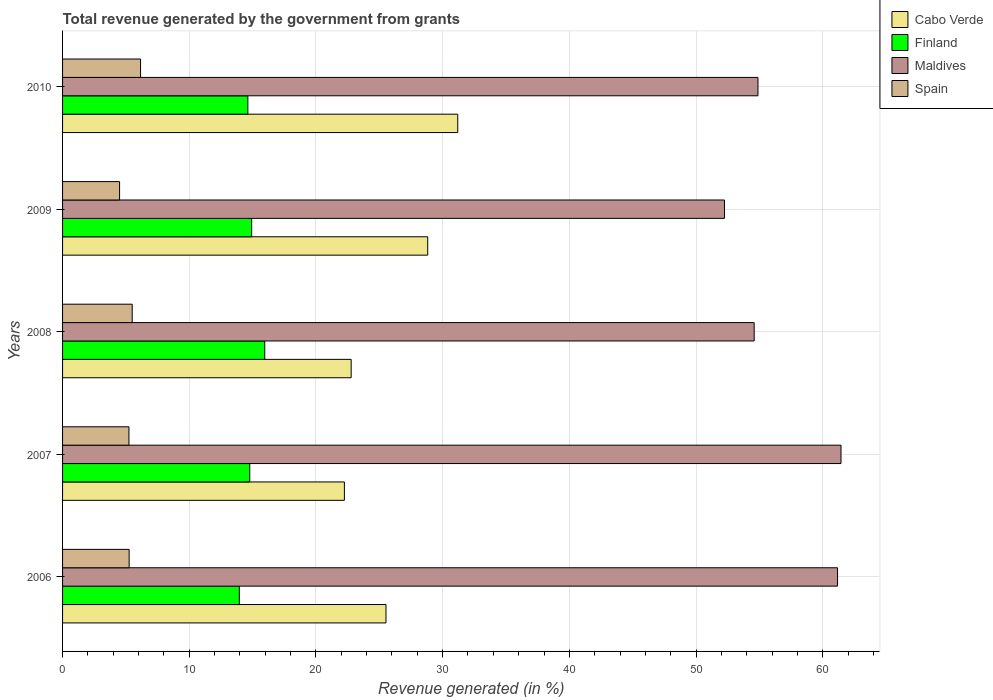How many different coloured bars are there?
Provide a succinct answer. 4. Are the number of bars on each tick of the Y-axis equal?
Make the answer very short. Yes. What is the total revenue generated in Spain in 2009?
Ensure brevity in your answer.  4.5. Across all years, what is the maximum total revenue generated in Spain?
Make the answer very short. 6.16. Across all years, what is the minimum total revenue generated in Maldives?
Ensure brevity in your answer.  52.25. In which year was the total revenue generated in Spain minimum?
Give a very brief answer. 2009. What is the total total revenue generated in Finland in the graph?
Offer a very short reply. 74.24. What is the difference between the total revenue generated in Cabo Verde in 2006 and that in 2010?
Give a very brief answer. -5.66. What is the difference between the total revenue generated in Maldives in 2010 and the total revenue generated in Cabo Verde in 2009?
Provide a succinct answer. 26.07. What is the average total revenue generated in Maldives per year?
Keep it short and to the point. 56.87. In the year 2009, what is the difference between the total revenue generated in Finland and total revenue generated in Maldives?
Provide a short and direct response. -37.32. What is the ratio of the total revenue generated in Maldives in 2006 to that in 2010?
Your answer should be very brief. 1.11. Is the difference between the total revenue generated in Finland in 2006 and 2008 greater than the difference between the total revenue generated in Maldives in 2006 and 2008?
Offer a terse response. No. What is the difference between the highest and the second highest total revenue generated in Finland?
Make the answer very short. 1.03. What is the difference between the highest and the lowest total revenue generated in Maldives?
Ensure brevity in your answer.  9.2. In how many years, is the total revenue generated in Finland greater than the average total revenue generated in Finland taken over all years?
Ensure brevity in your answer.  2. What does the 1st bar from the top in 2008 represents?
Offer a terse response. Spain. Is it the case that in every year, the sum of the total revenue generated in Cabo Verde and total revenue generated in Finland is greater than the total revenue generated in Maldives?
Offer a terse response. No. How many years are there in the graph?
Make the answer very short. 5. Are the values on the major ticks of X-axis written in scientific E-notation?
Provide a short and direct response. No. Does the graph contain any zero values?
Give a very brief answer. No. Where does the legend appear in the graph?
Offer a very short reply. Top right. How many legend labels are there?
Make the answer very short. 4. How are the legend labels stacked?
Provide a succinct answer. Vertical. What is the title of the graph?
Your response must be concise. Total revenue generated by the government from grants. Does "Azerbaijan" appear as one of the legend labels in the graph?
Your answer should be very brief. No. What is the label or title of the X-axis?
Ensure brevity in your answer.  Revenue generated (in %). What is the Revenue generated (in %) in Cabo Verde in 2006?
Your answer should be compact. 25.53. What is the Revenue generated (in %) of Finland in 2006?
Offer a very short reply. 13.95. What is the Revenue generated (in %) of Maldives in 2006?
Provide a short and direct response. 61.17. What is the Revenue generated (in %) of Spain in 2006?
Your answer should be very brief. 5.26. What is the Revenue generated (in %) in Cabo Verde in 2007?
Make the answer very short. 22.25. What is the Revenue generated (in %) in Finland in 2007?
Keep it short and to the point. 14.78. What is the Revenue generated (in %) in Maldives in 2007?
Your answer should be very brief. 61.44. What is the Revenue generated (in %) of Spain in 2007?
Your answer should be very brief. 5.24. What is the Revenue generated (in %) of Cabo Verde in 2008?
Provide a short and direct response. 22.78. What is the Revenue generated (in %) in Finland in 2008?
Your response must be concise. 15.96. What is the Revenue generated (in %) in Maldives in 2008?
Provide a succinct answer. 54.59. What is the Revenue generated (in %) in Spain in 2008?
Ensure brevity in your answer.  5.5. What is the Revenue generated (in %) in Cabo Verde in 2009?
Keep it short and to the point. 28.82. What is the Revenue generated (in %) of Finland in 2009?
Provide a short and direct response. 14.93. What is the Revenue generated (in %) in Maldives in 2009?
Offer a terse response. 52.25. What is the Revenue generated (in %) in Spain in 2009?
Provide a short and direct response. 4.5. What is the Revenue generated (in %) in Cabo Verde in 2010?
Provide a succinct answer. 31.19. What is the Revenue generated (in %) of Finland in 2010?
Offer a very short reply. 14.62. What is the Revenue generated (in %) of Maldives in 2010?
Ensure brevity in your answer.  54.89. What is the Revenue generated (in %) in Spain in 2010?
Offer a terse response. 6.16. Across all years, what is the maximum Revenue generated (in %) of Cabo Verde?
Provide a succinct answer. 31.19. Across all years, what is the maximum Revenue generated (in %) in Finland?
Your answer should be very brief. 15.96. Across all years, what is the maximum Revenue generated (in %) of Maldives?
Give a very brief answer. 61.44. Across all years, what is the maximum Revenue generated (in %) of Spain?
Offer a very short reply. 6.16. Across all years, what is the minimum Revenue generated (in %) of Cabo Verde?
Keep it short and to the point. 22.25. Across all years, what is the minimum Revenue generated (in %) in Finland?
Provide a short and direct response. 13.95. Across all years, what is the minimum Revenue generated (in %) in Maldives?
Offer a very short reply. 52.25. Across all years, what is the minimum Revenue generated (in %) in Spain?
Your answer should be very brief. 4.5. What is the total Revenue generated (in %) of Cabo Verde in the graph?
Keep it short and to the point. 130.57. What is the total Revenue generated (in %) of Finland in the graph?
Your response must be concise. 74.24. What is the total Revenue generated (in %) in Maldives in the graph?
Provide a short and direct response. 284.34. What is the total Revenue generated (in %) of Spain in the graph?
Keep it short and to the point. 26.65. What is the difference between the Revenue generated (in %) in Cabo Verde in 2006 and that in 2007?
Your response must be concise. 3.28. What is the difference between the Revenue generated (in %) of Finland in 2006 and that in 2007?
Provide a succinct answer. -0.82. What is the difference between the Revenue generated (in %) of Maldives in 2006 and that in 2007?
Your answer should be very brief. -0.27. What is the difference between the Revenue generated (in %) in Spain in 2006 and that in 2007?
Your answer should be very brief. 0.02. What is the difference between the Revenue generated (in %) of Cabo Verde in 2006 and that in 2008?
Make the answer very short. 2.75. What is the difference between the Revenue generated (in %) in Finland in 2006 and that in 2008?
Your answer should be very brief. -2.01. What is the difference between the Revenue generated (in %) in Maldives in 2006 and that in 2008?
Keep it short and to the point. 6.58. What is the difference between the Revenue generated (in %) in Spain in 2006 and that in 2008?
Make the answer very short. -0.24. What is the difference between the Revenue generated (in %) of Cabo Verde in 2006 and that in 2009?
Your response must be concise. -3.29. What is the difference between the Revenue generated (in %) in Finland in 2006 and that in 2009?
Offer a terse response. -0.97. What is the difference between the Revenue generated (in %) in Maldives in 2006 and that in 2009?
Offer a terse response. 8.93. What is the difference between the Revenue generated (in %) of Spain in 2006 and that in 2009?
Provide a succinct answer. 0.75. What is the difference between the Revenue generated (in %) of Cabo Verde in 2006 and that in 2010?
Make the answer very short. -5.66. What is the difference between the Revenue generated (in %) in Finland in 2006 and that in 2010?
Offer a very short reply. -0.67. What is the difference between the Revenue generated (in %) in Maldives in 2006 and that in 2010?
Keep it short and to the point. 6.28. What is the difference between the Revenue generated (in %) in Spain in 2006 and that in 2010?
Your response must be concise. -0.9. What is the difference between the Revenue generated (in %) in Cabo Verde in 2007 and that in 2008?
Provide a succinct answer. -0.53. What is the difference between the Revenue generated (in %) in Finland in 2007 and that in 2008?
Keep it short and to the point. -1.18. What is the difference between the Revenue generated (in %) of Maldives in 2007 and that in 2008?
Keep it short and to the point. 6.85. What is the difference between the Revenue generated (in %) in Spain in 2007 and that in 2008?
Provide a succinct answer. -0.26. What is the difference between the Revenue generated (in %) in Cabo Verde in 2007 and that in 2009?
Your answer should be very brief. -6.58. What is the difference between the Revenue generated (in %) of Finland in 2007 and that in 2009?
Offer a very short reply. -0.15. What is the difference between the Revenue generated (in %) in Maldives in 2007 and that in 2009?
Provide a short and direct response. 9.2. What is the difference between the Revenue generated (in %) in Spain in 2007 and that in 2009?
Provide a succinct answer. 0.74. What is the difference between the Revenue generated (in %) of Cabo Verde in 2007 and that in 2010?
Provide a succinct answer. -8.95. What is the difference between the Revenue generated (in %) of Finland in 2007 and that in 2010?
Offer a very short reply. 0.15. What is the difference between the Revenue generated (in %) in Maldives in 2007 and that in 2010?
Make the answer very short. 6.55. What is the difference between the Revenue generated (in %) of Spain in 2007 and that in 2010?
Offer a very short reply. -0.92. What is the difference between the Revenue generated (in %) in Cabo Verde in 2008 and that in 2009?
Ensure brevity in your answer.  -6.04. What is the difference between the Revenue generated (in %) in Finland in 2008 and that in 2009?
Give a very brief answer. 1.03. What is the difference between the Revenue generated (in %) in Maldives in 2008 and that in 2009?
Provide a short and direct response. 2.34. What is the difference between the Revenue generated (in %) in Spain in 2008 and that in 2009?
Give a very brief answer. 1. What is the difference between the Revenue generated (in %) in Cabo Verde in 2008 and that in 2010?
Provide a short and direct response. -8.41. What is the difference between the Revenue generated (in %) in Finland in 2008 and that in 2010?
Your answer should be very brief. 1.33. What is the difference between the Revenue generated (in %) in Maldives in 2008 and that in 2010?
Your answer should be very brief. -0.3. What is the difference between the Revenue generated (in %) in Spain in 2008 and that in 2010?
Ensure brevity in your answer.  -0.66. What is the difference between the Revenue generated (in %) in Cabo Verde in 2009 and that in 2010?
Your response must be concise. -2.37. What is the difference between the Revenue generated (in %) in Finland in 2009 and that in 2010?
Your answer should be compact. 0.3. What is the difference between the Revenue generated (in %) in Maldives in 2009 and that in 2010?
Your response must be concise. -2.64. What is the difference between the Revenue generated (in %) of Spain in 2009 and that in 2010?
Keep it short and to the point. -1.66. What is the difference between the Revenue generated (in %) of Cabo Verde in 2006 and the Revenue generated (in %) of Finland in 2007?
Give a very brief answer. 10.75. What is the difference between the Revenue generated (in %) in Cabo Verde in 2006 and the Revenue generated (in %) in Maldives in 2007?
Ensure brevity in your answer.  -35.92. What is the difference between the Revenue generated (in %) in Cabo Verde in 2006 and the Revenue generated (in %) in Spain in 2007?
Give a very brief answer. 20.29. What is the difference between the Revenue generated (in %) in Finland in 2006 and the Revenue generated (in %) in Maldives in 2007?
Your answer should be compact. -47.49. What is the difference between the Revenue generated (in %) of Finland in 2006 and the Revenue generated (in %) of Spain in 2007?
Provide a succinct answer. 8.71. What is the difference between the Revenue generated (in %) in Maldives in 2006 and the Revenue generated (in %) in Spain in 2007?
Provide a succinct answer. 55.93. What is the difference between the Revenue generated (in %) of Cabo Verde in 2006 and the Revenue generated (in %) of Finland in 2008?
Provide a succinct answer. 9.57. What is the difference between the Revenue generated (in %) in Cabo Verde in 2006 and the Revenue generated (in %) in Maldives in 2008?
Give a very brief answer. -29.06. What is the difference between the Revenue generated (in %) in Cabo Verde in 2006 and the Revenue generated (in %) in Spain in 2008?
Make the answer very short. 20.03. What is the difference between the Revenue generated (in %) in Finland in 2006 and the Revenue generated (in %) in Maldives in 2008?
Your answer should be compact. -40.64. What is the difference between the Revenue generated (in %) in Finland in 2006 and the Revenue generated (in %) in Spain in 2008?
Your response must be concise. 8.45. What is the difference between the Revenue generated (in %) in Maldives in 2006 and the Revenue generated (in %) in Spain in 2008?
Offer a terse response. 55.67. What is the difference between the Revenue generated (in %) in Cabo Verde in 2006 and the Revenue generated (in %) in Finland in 2009?
Provide a succinct answer. 10.6. What is the difference between the Revenue generated (in %) of Cabo Verde in 2006 and the Revenue generated (in %) of Maldives in 2009?
Give a very brief answer. -26.72. What is the difference between the Revenue generated (in %) in Cabo Verde in 2006 and the Revenue generated (in %) in Spain in 2009?
Your response must be concise. 21.03. What is the difference between the Revenue generated (in %) in Finland in 2006 and the Revenue generated (in %) in Maldives in 2009?
Your answer should be very brief. -38.29. What is the difference between the Revenue generated (in %) of Finland in 2006 and the Revenue generated (in %) of Spain in 2009?
Provide a short and direct response. 9.45. What is the difference between the Revenue generated (in %) in Maldives in 2006 and the Revenue generated (in %) in Spain in 2009?
Your answer should be compact. 56.67. What is the difference between the Revenue generated (in %) of Cabo Verde in 2006 and the Revenue generated (in %) of Finland in 2010?
Your answer should be very brief. 10.9. What is the difference between the Revenue generated (in %) in Cabo Verde in 2006 and the Revenue generated (in %) in Maldives in 2010?
Offer a very short reply. -29.36. What is the difference between the Revenue generated (in %) of Cabo Verde in 2006 and the Revenue generated (in %) of Spain in 2010?
Ensure brevity in your answer.  19.37. What is the difference between the Revenue generated (in %) of Finland in 2006 and the Revenue generated (in %) of Maldives in 2010?
Provide a succinct answer. -40.94. What is the difference between the Revenue generated (in %) in Finland in 2006 and the Revenue generated (in %) in Spain in 2010?
Offer a very short reply. 7.79. What is the difference between the Revenue generated (in %) in Maldives in 2006 and the Revenue generated (in %) in Spain in 2010?
Your answer should be compact. 55.01. What is the difference between the Revenue generated (in %) in Cabo Verde in 2007 and the Revenue generated (in %) in Finland in 2008?
Provide a short and direct response. 6.29. What is the difference between the Revenue generated (in %) of Cabo Verde in 2007 and the Revenue generated (in %) of Maldives in 2008?
Provide a short and direct response. -32.34. What is the difference between the Revenue generated (in %) in Cabo Verde in 2007 and the Revenue generated (in %) in Spain in 2008?
Make the answer very short. 16.75. What is the difference between the Revenue generated (in %) of Finland in 2007 and the Revenue generated (in %) of Maldives in 2008?
Provide a short and direct response. -39.81. What is the difference between the Revenue generated (in %) in Finland in 2007 and the Revenue generated (in %) in Spain in 2008?
Your answer should be very brief. 9.28. What is the difference between the Revenue generated (in %) in Maldives in 2007 and the Revenue generated (in %) in Spain in 2008?
Provide a succinct answer. 55.95. What is the difference between the Revenue generated (in %) in Cabo Verde in 2007 and the Revenue generated (in %) in Finland in 2009?
Ensure brevity in your answer.  7.32. What is the difference between the Revenue generated (in %) of Cabo Verde in 2007 and the Revenue generated (in %) of Maldives in 2009?
Ensure brevity in your answer.  -30. What is the difference between the Revenue generated (in %) of Cabo Verde in 2007 and the Revenue generated (in %) of Spain in 2009?
Give a very brief answer. 17.74. What is the difference between the Revenue generated (in %) in Finland in 2007 and the Revenue generated (in %) in Maldives in 2009?
Your response must be concise. -37.47. What is the difference between the Revenue generated (in %) in Finland in 2007 and the Revenue generated (in %) in Spain in 2009?
Provide a short and direct response. 10.27. What is the difference between the Revenue generated (in %) of Maldives in 2007 and the Revenue generated (in %) of Spain in 2009?
Your answer should be very brief. 56.94. What is the difference between the Revenue generated (in %) of Cabo Verde in 2007 and the Revenue generated (in %) of Finland in 2010?
Make the answer very short. 7.62. What is the difference between the Revenue generated (in %) of Cabo Verde in 2007 and the Revenue generated (in %) of Maldives in 2010?
Give a very brief answer. -32.64. What is the difference between the Revenue generated (in %) of Cabo Verde in 2007 and the Revenue generated (in %) of Spain in 2010?
Make the answer very short. 16.09. What is the difference between the Revenue generated (in %) of Finland in 2007 and the Revenue generated (in %) of Maldives in 2010?
Make the answer very short. -40.11. What is the difference between the Revenue generated (in %) in Finland in 2007 and the Revenue generated (in %) in Spain in 2010?
Ensure brevity in your answer.  8.62. What is the difference between the Revenue generated (in %) in Maldives in 2007 and the Revenue generated (in %) in Spain in 2010?
Ensure brevity in your answer.  55.29. What is the difference between the Revenue generated (in %) in Cabo Verde in 2008 and the Revenue generated (in %) in Finland in 2009?
Your answer should be compact. 7.85. What is the difference between the Revenue generated (in %) of Cabo Verde in 2008 and the Revenue generated (in %) of Maldives in 2009?
Ensure brevity in your answer.  -29.47. What is the difference between the Revenue generated (in %) of Cabo Verde in 2008 and the Revenue generated (in %) of Spain in 2009?
Your response must be concise. 18.28. What is the difference between the Revenue generated (in %) of Finland in 2008 and the Revenue generated (in %) of Maldives in 2009?
Offer a very short reply. -36.29. What is the difference between the Revenue generated (in %) of Finland in 2008 and the Revenue generated (in %) of Spain in 2009?
Provide a succinct answer. 11.46. What is the difference between the Revenue generated (in %) of Maldives in 2008 and the Revenue generated (in %) of Spain in 2009?
Offer a terse response. 50.09. What is the difference between the Revenue generated (in %) in Cabo Verde in 2008 and the Revenue generated (in %) in Finland in 2010?
Offer a very short reply. 8.15. What is the difference between the Revenue generated (in %) of Cabo Verde in 2008 and the Revenue generated (in %) of Maldives in 2010?
Keep it short and to the point. -32.11. What is the difference between the Revenue generated (in %) of Cabo Verde in 2008 and the Revenue generated (in %) of Spain in 2010?
Your answer should be compact. 16.62. What is the difference between the Revenue generated (in %) in Finland in 2008 and the Revenue generated (in %) in Maldives in 2010?
Offer a terse response. -38.93. What is the difference between the Revenue generated (in %) in Finland in 2008 and the Revenue generated (in %) in Spain in 2010?
Make the answer very short. 9.8. What is the difference between the Revenue generated (in %) of Maldives in 2008 and the Revenue generated (in %) of Spain in 2010?
Offer a very short reply. 48.43. What is the difference between the Revenue generated (in %) of Cabo Verde in 2009 and the Revenue generated (in %) of Finland in 2010?
Keep it short and to the point. 14.2. What is the difference between the Revenue generated (in %) in Cabo Verde in 2009 and the Revenue generated (in %) in Maldives in 2010?
Offer a terse response. -26.07. What is the difference between the Revenue generated (in %) of Cabo Verde in 2009 and the Revenue generated (in %) of Spain in 2010?
Keep it short and to the point. 22.67. What is the difference between the Revenue generated (in %) of Finland in 2009 and the Revenue generated (in %) of Maldives in 2010?
Provide a short and direct response. -39.96. What is the difference between the Revenue generated (in %) in Finland in 2009 and the Revenue generated (in %) in Spain in 2010?
Offer a very short reply. 8.77. What is the difference between the Revenue generated (in %) of Maldives in 2009 and the Revenue generated (in %) of Spain in 2010?
Provide a succinct answer. 46.09. What is the average Revenue generated (in %) of Cabo Verde per year?
Provide a succinct answer. 26.11. What is the average Revenue generated (in %) in Finland per year?
Make the answer very short. 14.85. What is the average Revenue generated (in %) of Maldives per year?
Offer a very short reply. 56.87. What is the average Revenue generated (in %) of Spain per year?
Provide a succinct answer. 5.33. In the year 2006, what is the difference between the Revenue generated (in %) of Cabo Verde and Revenue generated (in %) of Finland?
Your answer should be compact. 11.58. In the year 2006, what is the difference between the Revenue generated (in %) of Cabo Verde and Revenue generated (in %) of Maldives?
Your answer should be compact. -35.64. In the year 2006, what is the difference between the Revenue generated (in %) in Cabo Verde and Revenue generated (in %) in Spain?
Offer a very short reply. 20.27. In the year 2006, what is the difference between the Revenue generated (in %) in Finland and Revenue generated (in %) in Maldives?
Make the answer very short. -47.22. In the year 2006, what is the difference between the Revenue generated (in %) of Finland and Revenue generated (in %) of Spain?
Keep it short and to the point. 8.7. In the year 2006, what is the difference between the Revenue generated (in %) of Maldives and Revenue generated (in %) of Spain?
Your answer should be very brief. 55.92. In the year 2007, what is the difference between the Revenue generated (in %) in Cabo Verde and Revenue generated (in %) in Finland?
Provide a succinct answer. 7.47. In the year 2007, what is the difference between the Revenue generated (in %) of Cabo Verde and Revenue generated (in %) of Maldives?
Keep it short and to the point. -39.2. In the year 2007, what is the difference between the Revenue generated (in %) in Cabo Verde and Revenue generated (in %) in Spain?
Keep it short and to the point. 17.01. In the year 2007, what is the difference between the Revenue generated (in %) in Finland and Revenue generated (in %) in Maldives?
Your answer should be compact. -46.67. In the year 2007, what is the difference between the Revenue generated (in %) of Finland and Revenue generated (in %) of Spain?
Your response must be concise. 9.54. In the year 2007, what is the difference between the Revenue generated (in %) of Maldives and Revenue generated (in %) of Spain?
Provide a short and direct response. 56.2. In the year 2008, what is the difference between the Revenue generated (in %) of Cabo Verde and Revenue generated (in %) of Finland?
Offer a very short reply. 6.82. In the year 2008, what is the difference between the Revenue generated (in %) in Cabo Verde and Revenue generated (in %) in Maldives?
Offer a very short reply. -31.81. In the year 2008, what is the difference between the Revenue generated (in %) of Cabo Verde and Revenue generated (in %) of Spain?
Your answer should be very brief. 17.28. In the year 2008, what is the difference between the Revenue generated (in %) in Finland and Revenue generated (in %) in Maldives?
Keep it short and to the point. -38.63. In the year 2008, what is the difference between the Revenue generated (in %) in Finland and Revenue generated (in %) in Spain?
Offer a very short reply. 10.46. In the year 2008, what is the difference between the Revenue generated (in %) of Maldives and Revenue generated (in %) of Spain?
Provide a short and direct response. 49.09. In the year 2009, what is the difference between the Revenue generated (in %) of Cabo Verde and Revenue generated (in %) of Finland?
Keep it short and to the point. 13.9. In the year 2009, what is the difference between the Revenue generated (in %) of Cabo Verde and Revenue generated (in %) of Maldives?
Make the answer very short. -23.42. In the year 2009, what is the difference between the Revenue generated (in %) in Cabo Verde and Revenue generated (in %) in Spain?
Your answer should be very brief. 24.32. In the year 2009, what is the difference between the Revenue generated (in %) of Finland and Revenue generated (in %) of Maldives?
Keep it short and to the point. -37.32. In the year 2009, what is the difference between the Revenue generated (in %) of Finland and Revenue generated (in %) of Spain?
Offer a terse response. 10.42. In the year 2009, what is the difference between the Revenue generated (in %) in Maldives and Revenue generated (in %) in Spain?
Provide a short and direct response. 47.74. In the year 2010, what is the difference between the Revenue generated (in %) of Cabo Verde and Revenue generated (in %) of Finland?
Ensure brevity in your answer.  16.57. In the year 2010, what is the difference between the Revenue generated (in %) of Cabo Verde and Revenue generated (in %) of Maldives?
Your answer should be compact. -23.7. In the year 2010, what is the difference between the Revenue generated (in %) of Cabo Verde and Revenue generated (in %) of Spain?
Provide a short and direct response. 25.04. In the year 2010, what is the difference between the Revenue generated (in %) in Finland and Revenue generated (in %) in Maldives?
Ensure brevity in your answer.  -40.26. In the year 2010, what is the difference between the Revenue generated (in %) in Finland and Revenue generated (in %) in Spain?
Your answer should be compact. 8.47. In the year 2010, what is the difference between the Revenue generated (in %) in Maldives and Revenue generated (in %) in Spain?
Offer a terse response. 48.73. What is the ratio of the Revenue generated (in %) in Cabo Verde in 2006 to that in 2007?
Offer a terse response. 1.15. What is the ratio of the Revenue generated (in %) in Finland in 2006 to that in 2007?
Provide a short and direct response. 0.94. What is the ratio of the Revenue generated (in %) in Maldives in 2006 to that in 2007?
Your response must be concise. 1. What is the ratio of the Revenue generated (in %) of Spain in 2006 to that in 2007?
Provide a succinct answer. 1. What is the ratio of the Revenue generated (in %) in Cabo Verde in 2006 to that in 2008?
Offer a very short reply. 1.12. What is the ratio of the Revenue generated (in %) in Finland in 2006 to that in 2008?
Your answer should be compact. 0.87. What is the ratio of the Revenue generated (in %) in Maldives in 2006 to that in 2008?
Your response must be concise. 1.12. What is the ratio of the Revenue generated (in %) in Spain in 2006 to that in 2008?
Keep it short and to the point. 0.96. What is the ratio of the Revenue generated (in %) in Cabo Verde in 2006 to that in 2009?
Keep it short and to the point. 0.89. What is the ratio of the Revenue generated (in %) of Finland in 2006 to that in 2009?
Ensure brevity in your answer.  0.93. What is the ratio of the Revenue generated (in %) in Maldives in 2006 to that in 2009?
Provide a short and direct response. 1.17. What is the ratio of the Revenue generated (in %) of Spain in 2006 to that in 2009?
Your answer should be compact. 1.17. What is the ratio of the Revenue generated (in %) of Cabo Verde in 2006 to that in 2010?
Provide a short and direct response. 0.82. What is the ratio of the Revenue generated (in %) of Finland in 2006 to that in 2010?
Ensure brevity in your answer.  0.95. What is the ratio of the Revenue generated (in %) of Maldives in 2006 to that in 2010?
Offer a very short reply. 1.11. What is the ratio of the Revenue generated (in %) in Spain in 2006 to that in 2010?
Your answer should be very brief. 0.85. What is the ratio of the Revenue generated (in %) of Cabo Verde in 2007 to that in 2008?
Keep it short and to the point. 0.98. What is the ratio of the Revenue generated (in %) of Finland in 2007 to that in 2008?
Make the answer very short. 0.93. What is the ratio of the Revenue generated (in %) in Maldives in 2007 to that in 2008?
Offer a terse response. 1.13. What is the ratio of the Revenue generated (in %) of Spain in 2007 to that in 2008?
Provide a succinct answer. 0.95. What is the ratio of the Revenue generated (in %) of Cabo Verde in 2007 to that in 2009?
Provide a short and direct response. 0.77. What is the ratio of the Revenue generated (in %) of Finland in 2007 to that in 2009?
Your response must be concise. 0.99. What is the ratio of the Revenue generated (in %) in Maldives in 2007 to that in 2009?
Give a very brief answer. 1.18. What is the ratio of the Revenue generated (in %) in Spain in 2007 to that in 2009?
Make the answer very short. 1.16. What is the ratio of the Revenue generated (in %) of Cabo Verde in 2007 to that in 2010?
Make the answer very short. 0.71. What is the ratio of the Revenue generated (in %) in Finland in 2007 to that in 2010?
Ensure brevity in your answer.  1.01. What is the ratio of the Revenue generated (in %) in Maldives in 2007 to that in 2010?
Keep it short and to the point. 1.12. What is the ratio of the Revenue generated (in %) in Spain in 2007 to that in 2010?
Provide a succinct answer. 0.85. What is the ratio of the Revenue generated (in %) in Cabo Verde in 2008 to that in 2009?
Your answer should be very brief. 0.79. What is the ratio of the Revenue generated (in %) of Finland in 2008 to that in 2009?
Give a very brief answer. 1.07. What is the ratio of the Revenue generated (in %) of Maldives in 2008 to that in 2009?
Give a very brief answer. 1.04. What is the ratio of the Revenue generated (in %) of Spain in 2008 to that in 2009?
Provide a short and direct response. 1.22. What is the ratio of the Revenue generated (in %) in Cabo Verde in 2008 to that in 2010?
Make the answer very short. 0.73. What is the ratio of the Revenue generated (in %) of Finland in 2008 to that in 2010?
Offer a very short reply. 1.09. What is the ratio of the Revenue generated (in %) in Maldives in 2008 to that in 2010?
Ensure brevity in your answer.  0.99. What is the ratio of the Revenue generated (in %) of Spain in 2008 to that in 2010?
Your response must be concise. 0.89. What is the ratio of the Revenue generated (in %) in Cabo Verde in 2009 to that in 2010?
Your answer should be very brief. 0.92. What is the ratio of the Revenue generated (in %) in Finland in 2009 to that in 2010?
Your answer should be very brief. 1.02. What is the ratio of the Revenue generated (in %) in Maldives in 2009 to that in 2010?
Offer a very short reply. 0.95. What is the ratio of the Revenue generated (in %) in Spain in 2009 to that in 2010?
Make the answer very short. 0.73. What is the difference between the highest and the second highest Revenue generated (in %) of Cabo Verde?
Your answer should be compact. 2.37. What is the difference between the highest and the second highest Revenue generated (in %) in Finland?
Make the answer very short. 1.03. What is the difference between the highest and the second highest Revenue generated (in %) in Maldives?
Your answer should be very brief. 0.27. What is the difference between the highest and the second highest Revenue generated (in %) in Spain?
Give a very brief answer. 0.66. What is the difference between the highest and the lowest Revenue generated (in %) in Cabo Verde?
Provide a short and direct response. 8.95. What is the difference between the highest and the lowest Revenue generated (in %) in Finland?
Make the answer very short. 2.01. What is the difference between the highest and the lowest Revenue generated (in %) in Maldives?
Your answer should be very brief. 9.2. What is the difference between the highest and the lowest Revenue generated (in %) of Spain?
Offer a terse response. 1.66. 